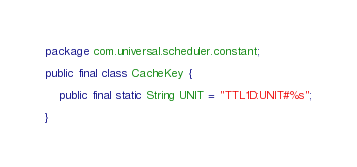<code> <loc_0><loc_0><loc_500><loc_500><_Java_>package com.universal.scheduler.constant;

public final class CacheKey {

    public final static String UNIT = "TTL1D:UNIT#%s";

}
</code> 